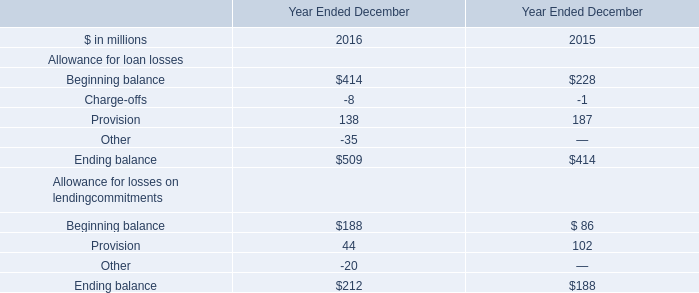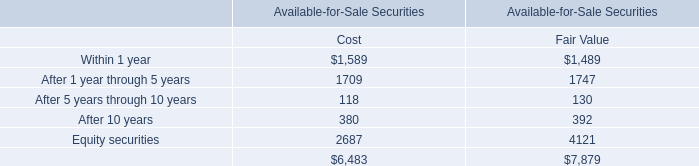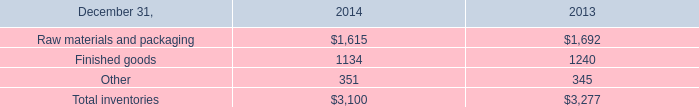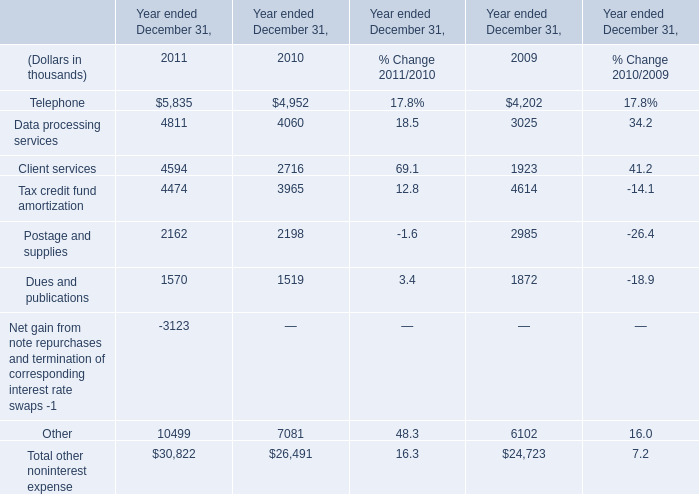What was the total amount of the other non interest expense in the years where Client services is greater than 4000? (in thousand) 
Computations: (((((((5835 + 4811) + 4594) + 4474) + 2162) + 1570) - 3123) + 10499)
Answer: 30822.0. 